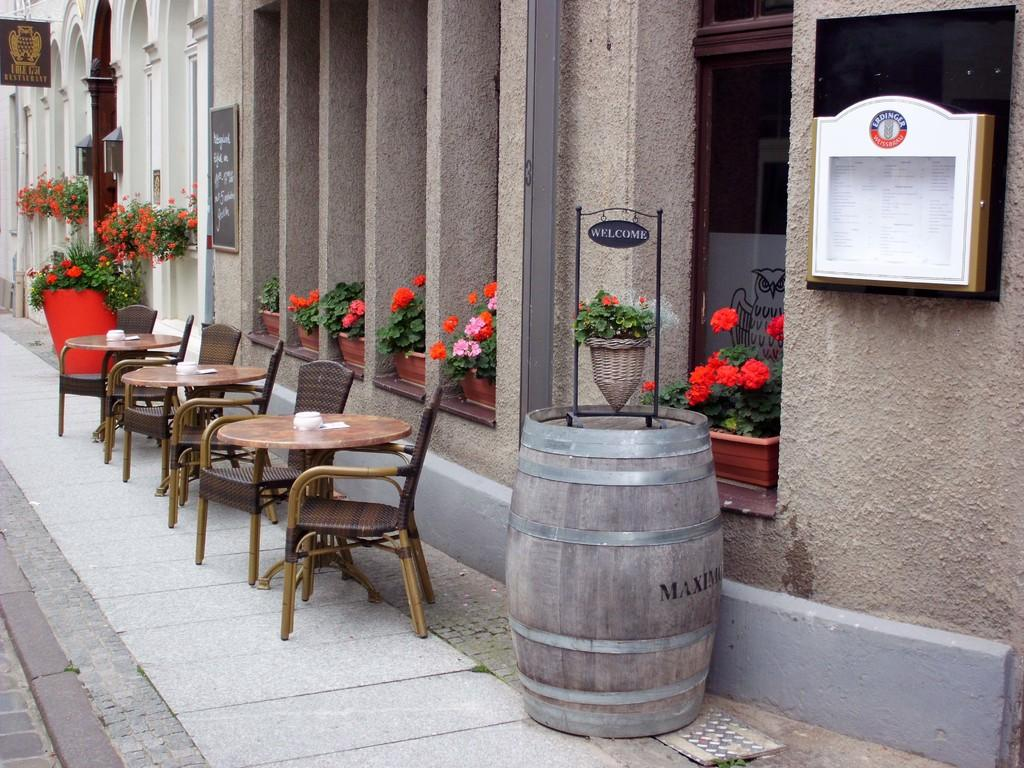What type of furniture is present in the image? There is a table and a chair in the image. What objects are used for decoration or gardening purposes? There are flower pots in the image. What architectural elements can be seen in the background of the image? There is a pillar, a board, and a wall in the background of the image. What type of button is being used to hold the interest of the viewers in the image? There is no button or reference to holding interest in the image; it features a table, a chair, flower pots, and architectural elements in the background. 